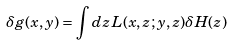Convert formula to latex. <formula><loc_0><loc_0><loc_500><loc_500>\delta g ( x , y ) = \int d z \, L ( x , z ; y , z ) \delta H ( z )</formula> 